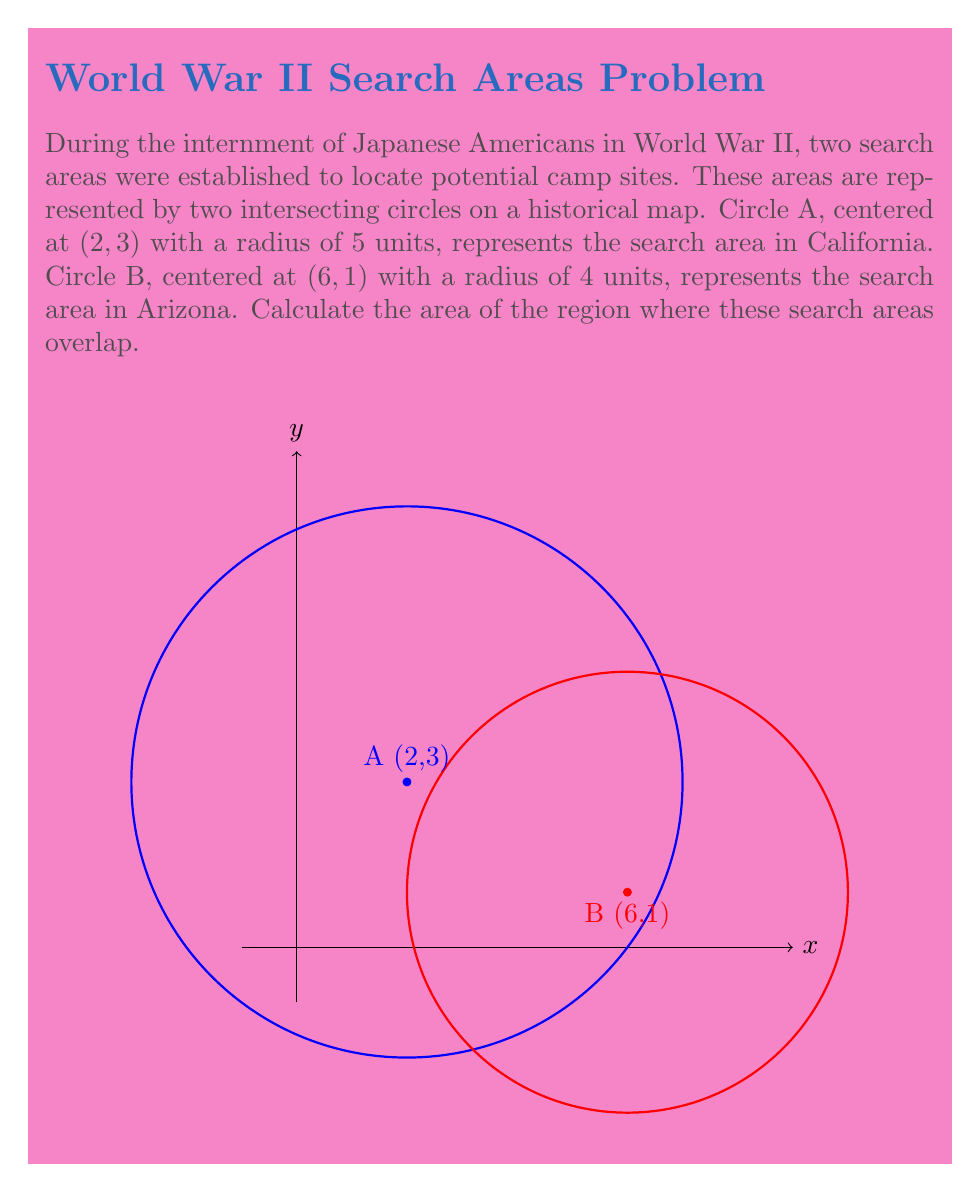Solve this math problem. To find the area of intersection between two circles, we can follow these steps:

1) First, we need to find the distance between the centers of the circles:
   $$d = \sqrt{(x_2-x_1)^2 + (y_2-y_1)^2} = \sqrt{(6-2)^2 + (1-3)^2} = \sqrt{16 + 4} = \sqrt{20} = 2\sqrt{5}$$

2) Now we can use the formula for the area of intersection of two circles:
   $$A = r_1^2 \arccos(\frac{d^2 + r_1^2 - r_2^2}{2dr_1}) + r_2^2 \arccos(\frac{d^2 + r_2^2 - r_1^2}{2dr_2}) - \frac{1}{2}\sqrt{(-d+r_1+r_2)(d+r_1-r_2)(d-r_1+r_2)(d+r_1+r_2)}$$

3) Let's substitute our values:
   $r_1 = 5, r_2 = 4, d = 2\sqrt{5}$

4) Calculating each part:
   $$\arccos(\frac{(2\sqrt{5})^2 + 5^2 - 4^2}{2(2\sqrt{5})(5)}) = \arccos(\frac{20 + 25 - 16}{20\sqrt{5}}) = \arccos(\frac{29}{20\sqrt{5}})$$
   $$\arccos(\frac{(2\sqrt{5})^2 + 4^2 - 5^2}{2(2\sqrt{5})(4)}) = \arccos(\frac{20 + 16 - 25}{16\sqrt{5}}) = \arccos(\frac{11}{16\sqrt{5}})$$
   $$\sqrt{(-2\sqrt{5}+5+4)(2\sqrt{5}+5-4)(2\sqrt{5}-5+4)(2\sqrt{5}+5+4)} = \sqrt{(9-2\sqrt{5})(1+2\sqrt{5})(2\sqrt{5}-1)(9+2\sqrt{5})}$$

5) Putting it all together:
   $$A = 25 \arccos(\frac{29}{20\sqrt{5}}) + 16 \arccos(\frac{11}{16\sqrt{5}}) - \frac{1}{2}\sqrt{(9-2\sqrt{5})(1+2\sqrt{5})(2\sqrt{5}-1)(9+2\sqrt{5})}$$

6) This expression can be evaluated numerically to get the final answer.
Answer: $25 \arccos(\frac{29}{20\sqrt{5}}) + 16 \arccos(\frac{11}{16\sqrt{5}}) - \frac{1}{2}\sqrt{(9-2\sqrt{5})(1+2\sqrt{5})(2\sqrt{5}-1)(9+2\sqrt{5})} \approx 11.77$ square units 